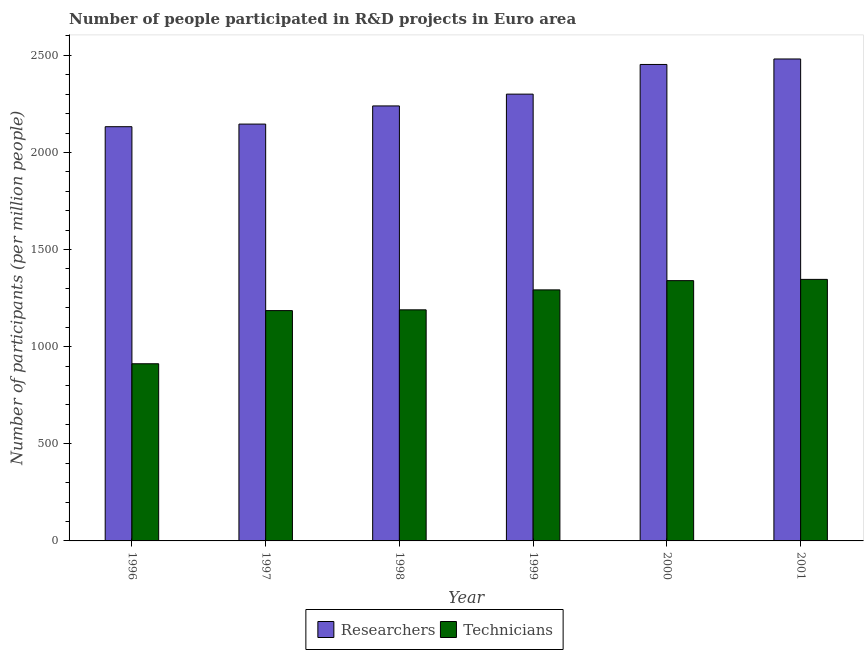How many different coloured bars are there?
Your response must be concise. 2. How many groups of bars are there?
Ensure brevity in your answer.  6. Are the number of bars per tick equal to the number of legend labels?
Ensure brevity in your answer.  Yes. What is the label of the 4th group of bars from the left?
Your response must be concise. 1999. What is the number of researchers in 1996?
Provide a short and direct response. 2132.59. Across all years, what is the maximum number of technicians?
Make the answer very short. 1346.52. Across all years, what is the minimum number of technicians?
Give a very brief answer. 912.13. In which year was the number of technicians maximum?
Your answer should be very brief. 2001. In which year was the number of technicians minimum?
Your answer should be very brief. 1996. What is the total number of researchers in the graph?
Provide a short and direct response. 1.38e+04. What is the difference between the number of technicians in 1999 and that in 2001?
Offer a terse response. -54.1. What is the difference between the number of researchers in 2000 and the number of technicians in 1996?
Your answer should be very brief. 320.41. What is the average number of technicians per year?
Your answer should be compact. 1211.11. What is the ratio of the number of technicians in 1996 to that in 2001?
Provide a short and direct response. 0.68. Is the number of researchers in 1997 less than that in 1999?
Provide a succinct answer. Yes. Is the difference between the number of researchers in 1998 and 2001 greater than the difference between the number of technicians in 1998 and 2001?
Provide a short and direct response. No. What is the difference between the highest and the second highest number of technicians?
Your response must be concise. 6.43. What is the difference between the highest and the lowest number of researchers?
Provide a short and direct response. 348.67. In how many years, is the number of technicians greater than the average number of technicians taken over all years?
Provide a succinct answer. 3. Is the sum of the number of researchers in 1996 and 2001 greater than the maximum number of technicians across all years?
Ensure brevity in your answer.  Yes. What does the 1st bar from the left in 1998 represents?
Ensure brevity in your answer.  Researchers. What does the 1st bar from the right in 1997 represents?
Your answer should be compact. Technicians. How many bars are there?
Offer a very short reply. 12. Are all the bars in the graph horizontal?
Offer a terse response. No. What is the difference between two consecutive major ticks on the Y-axis?
Give a very brief answer. 500. What is the title of the graph?
Your answer should be very brief. Number of people participated in R&D projects in Euro area. Does "All education staff compensation" appear as one of the legend labels in the graph?
Give a very brief answer. No. What is the label or title of the Y-axis?
Provide a short and direct response. Number of participants (per million people). What is the Number of participants (per million people) in Researchers in 1996?
Offer a very short reply. 2132.59. What is the Number of participants (per million people) in Technicians in 1996?
Offer a very short reply. 912.13. What is the Number of participants (per million people) in Researchers in 1997?
Give a very brief answer. 2146.05. What is the Number of participants (per million people) of Technicians in 1997?
Keep it short and to the point. 1185.77. What is the Number of participants (per million people) in Researchers in 1998?
Your response must be concise. 2239.52. What is the Number of participants (per million people) of Technicians in 1998?
Provide a succinct answer. 1189.74. What is the Number of participants (per million people) in Researchers in 1999?
Offer a very short reply. 2300.26. What is the Number of participants (per million people) of Technicians in 1999?
Offer a terse response. 1292.42. What is the Number of participants (per million people) in Researchers in 2000?
Make the answer very short. 2452.99. What is the Number of participants (per million people) of Technicians in 2000?
Give a very brief answer. 1340.09. What is the Number of participants (per million people) in Researchers in 2001?
Your answer should be compact. 2481.25. What is the Number of participants (per million people) in Technicians in 2001?
Ensure brevity in your answer.  1346.52. Across all years, what is the maximum Number of participants (per million people) of Researchers?
Keep it short and to the point. 2481.25. Across all years, what is the maximum Number of participants (per million people) of Technicians?
Your response must be concise. 1346.52. Across all years, what is the minimum Number of participants (per million people) in Researchers?
Give a very brief answer. 2132.59. Across all years, what is the minimum Number of participants (per million people) in Technicians?
Ensure brevity in your answer.  912.13. What is the total Number of participants (per million people) in Researchers in the graph?
Your answer should be compact. 1.38e+04. What is the total Number of participants (per million people) in Technicians in the graph?
Offer a very short reply. 7266.67. What is the difference between the Number of participants (per million people) of Researchers in 1996 and that in 1997?
Provide a short and direct response. -13.47. What is the difference between the Number of participants (per million people) in Technicians in 1996 and that in 1997?
Provide a succinct answer. -273.63. What is the difference between the Number of participants (per million people) of Researchers in 1996 and that in 1998?
Ensure brevity in your answer.  -106.94. What is the difference between the Number of participants (per million people) in Technicians in 1996 and that in 1998?
Ensure brevity in your answer.  -277.61. What is the difference between the Number of participants (per million people) in Researchers in 1996 and that in 1999?
Keep it short and to the point. -167.67. What is the difference between the Number of participants (per million people) of Technicians in 1996 and that in 1999?
Your answer should be very brief. -380.29. What is the difference between the Number of participants (per million people) in Researchers in 1996 and that in 2000?
Provide a short and direct response. -320.41. What is the difference between the Number of participants (per million people) of Technicians in 1996 and that in 2000?
Your response must be concise. -427.96. What is the difference between the Number of participants (per million people) in Researchers in 1996 and that in 2001?
Provide a succinct answer. -348.67. What is the difference between the Number of participants (per million people) of Technicians in 1996 and that in 2001?
Provide a succinct answer. -434.39. What is the difference between the Number of participants (per million people) of Researchers in 1997 and that in 1998?
Your answer should be compact. -93.47. What is the difference between the Number of participants (per million people) of Technicians in 1997 and that in 1998?
Offer a very short reply. -3.97. What is the difference between the Number of participants (per million people) in Researchers in 1997 and that in 1999?
Keep it short and to the point. -154.2. What is the difference between the Number of participants (per million people) of Technicians in 1997 and that in 1999?
Ensure brevity in your answer.  -106.66. What is the difference between the Number of participants (per million people) of Researchers in 1997 and that in 2000?
Keep it short and to the point. -306.94. What is the difference between the Number of participants (per million people) of Technicians in 1997 and that in 2000?
Offer a terse response. -154.33. What is the difference between the Number of participants (per million people) in Researchers in 1997 and that in 2001?
Offer a very short reply. -335.2. What is the difference between the Number of participants (per million people) in Technicians in 1997 and that in 2001?
Give a very brief answer. -160.75. What is the difference between the Number of participants (per million people) in Researchers in 1998 and that in 1999?
Ensure brevity in your answer.  -60.74. What is the difference between the Number of participants (per million people) of Technicians in 1998 and that in 1999?
Your answer should be compact. -102.68. What is the difference between the Number of participants (per million people) in Researchers in 1998 and that in 2000?
Offer a very short reply. -213.47. What is the difference between the Number of participants (per million people) of Technicians in 1998 and that in 2000?
Make the answer very short. -150.35. What is the difference between the Number of participants (per million people) of Researchers in 1998 and that in 2001?
Ensure brevity in your answer.  -241.73. What is the difference between the Number of participants (per million people) of Technicians in 1998 and that in 2001?
Your response must be concise. -156.78. What is the difference between the Number of participants (per million people) of Researchers in 1999 and that in 2000?
Make the answer very short. -152.73. What is the difference between the Number of participants (per million people) in Technicians in 1999 and that in 2000?
Give a very brief answer. -47.67. What is the difference between the Number of participants (per million people) in Researchers in 1999 and that in 2001?
Give a very brief answer. -181. What is the difference between the Number of participants (per million people) in Technicians in 1999 and that in 2001?
Make the answer very short. -54.1. What is the difference between the Number of participants (per million people) in Researchers in 2000 and that in 2001?
Offer a very short reply. -28.26. What is the difference between the Number of participants (per million people) in Technicians in 2000 and that in 2001?
Ensure brevity in your answer.  -6.43. What is the difference between the Number of participants (per million people) of Researchers in 1996 and the Number of participants (per million people) of Technicians in 1997?
Offer a terse response. 946.82. What is the difference between the Number of participants (per million people) of Researchers in 1996 and the Number of participants (per million people) of Technicians in 1998?
Provide a short and direct response. 942.85. What is the difference between the Number of participants (per million people) in Researchers in 1996 and the Number of participants (per million people) in Technicians in 1999?
Offer a very short reply. 840.16. What is the difference between the Number of participants (per million people) of Researchers in 1996 and the Number of participants (per million people) of Technicians in 2000?
Your answer should be compact. 792.49. What is the difference between the Number of participants (per million people) in Researchers in 1996 and the Number of participants (per million people) in Technicians in 2001?
Your answer should be compact. 786.07. What is the difference between the Number of participants (per million people) of Researchers in 1997 and the Number of participants (per million people) of Technicians in 1998?
Make the answer very short. 956.31. What is the difference between the Number of participants (per million people) of Researchers in 1997 and the Number of participants (per million people) of Technicians in 1999?
Make the answer very short. 853.63. What is the difference between the Number of participants (per million people) of Researchers in 1997 and the Number of participants (per million people) of Technicians in 2000?
Keep it short and to the point. 805.96. What is the difference between the Number of participants (per million people) of Researchers in 1997 and the Number of participants (per million people) of Technicians in 2001?
Make the answer very short. 799.53. What is the difference between the Number of participants (per million people) in Researchers in 1998 and the Number of participants (per million people) in Technicians in 1999?
Your answer should be very brief. 947.1. What is the difference between the Number of participants (per million people) in Researchers in 1998 and the Number of participants (per million people) in Technicians in 2000?
Provide a short and direct response. 899.43. What is the difference between the Number of participants (per million people) in Researchers in 1998 and the Number of participants (per million people) in Technicians in 2001?
Give a very brief answer. 893. What is the difference between the Number of participants (per million people) in Researchers in 1999 and the Number of participants (per million people) in Technicians in 2000?
Give a very brief answer. 960.17. What is the difference between the Number of participants (per million people) of Researchers in 1999 and the Number of participants (per million people) of Technicians in 2001?
Give a very brief answer. 953.74. What is the difference between the Number of participants (per million people) in Researchers in 2000 and the Number of participants (per million people) in Technicians in 2001?
Provide a short and direct response. 1106.47. What is the average Number of participants (per million people) of Researchers per year?
Offer a terse response. 2292.11. What is the average Number of participants (per million people) in Technicians per year?
Keep it short and to the point. 1211.11. In the year 1996, what is the difference between the Number of participants (per million people) in Researchers and Number of participants (per million people) in Technicians?
Give a very brief answer. 1220.45. In the year 1997, what is the difference between the Number of participants (per million people) of Researchers and Number of participants (per million people) of Technicians?
Offer a terse response. 960.29. In the year 1998, what is the difference between the Number of participants (per million people) of Researchers and Number of participants (per million people) of Technicians?
Give a very brief answer. 1049.78. In the year 1999, what is the difference between the Number of participants (per million people) of Researchers and Number of participants (per million people) of Technicians?
Keep it short and to the point. 1007.84. In the year 2000, what is the difference between the Number of participants (per million people) of Researchers and Number of participants (per million people) of Technicians?
Give a very brief answer. 1112.9. In the year 2001, what is the difference between the Number of participants (per million people) of Researchers and Number of participants (per million people) of Technicians?
Your answer should be very brief. 1134.73. What is the ratio of the Number of participants (per million people) of Researchers in 1996 to that in 1997?
Keep it short and to the point. 0.99. What is the ratio of the Number of participants (per million people) of Technicians in 1996 to that in 1997?
Your answer should be compact. 0.77. What is the ratio of the Number of participants (per million people) in Researchers in 1996 to that in 1998?
Offer a very short reply. 0.95. What is the ratio of the Number of participants (per million people) in Technicians in 1996 to that in 1998?
Provide a succinct answer. 0.77. What is the ratio of the Number of participants (per million people) of Researchers in 1996 to that in 1999?
Ensure brevity in your answer.  0.93. What is the ratio of the Number of participants (per million people) of Technicians in 1996 to that in 1999?
Give a very brief answer. 0.71. What is the ratio of the Number of participants (per million people) of Researchers in 1996 to that in 2000?
Keep it short and to the point. 0.87. What is the ratio of the Number of participants (per million people) in Technicians in 1996 to that in 2000?
Your answer should be compact. 0.68. What is the ratio of the Number of participants (per million people) in Researchers in 1996 to that in 2001?
Give a very brief answer. 0.86. What is the ratio of the Number of participants (per million people) in Technicians in 1996 to that in 2001?
Your answer should be very brief. 0.68. What is the ratio of the Number of participants (per million people) in Researchers in 1997 to that in 1999?
Offer a terse response. 0.93. What is the ratio of the Number of participants (per million people) of Technicians in 1997 to that in 1999?
Provide a succinct answer. 0.92. What is the ratio of the Number of participants (per million people) of Researchers in 1997 to that in 2000?
Offer a very short reply. 0.87. What is the ratio of the Number of participants (per million people) of Technicians in 1997 to that in 2000?
Offer a terse response. 0.88. What is the ratio of the Number of participants (per million people) in Researchers in 1997 to that in 2001?
Your answer should be compact. 0.86. What is the ratio of the Number of participants (per million people) in Technicians in 1997 to that in 2001?
Your response must be concise. 0.88. What is the ratio of the Number of participants (per million people) in Researchers in 1998 to that in 1999?
Offer a very short reply. 0.97. What is the ratio of the Number of participants (per million people) in Technicians in 1998 to that in 1999?
Your answer should be very brief. 0.92. What is the ratio of the Number of participants (per million people) in Technicians in 1998 to that in 2000?
Ensure brevity in your answer.  0.89. What is the ratio of the Number of participants (per million people) in Researchers in 1998 to that in 2001?
Give a very brief answer. 0.9. What is the ratio of the Number of participants (per million people) in Technicians in 1998 to that in 2001?
Make the answer very short. 0.88. What is the ratio of the Number of participants (per million people) of Researchers in 1999 to that in 2000?
Offer a very short reply. 0.94. What is the ratio of the Number of participants (per million people) of Technicians in 1999 to that in 2000?
Offer a very short reply. 0.96. What is the ratio of the Number of participants (per million people) of Researchers in 1999 to that in 2001?
Offer a terse response. 0.93. What is the ratio of the Number of participants (per million people) of Technicians in 1999 to that in 2001?
Keep it short and to the point. 0.96. What is the ratio of the Number of participants (per million people) in Technicians in 2000 to that in 2001?
Your response must be concise. 1. What is the difference between the highest and the second highest Number of participants (per million people) in Researchers?
Keep it short and to the point. 28.26. What is the difference between the highest and the second highest Number of participants (per million people) of Technicians?
Your answer should be very brief. 6.43. What is the difference between the highest and the lowest Number of participants (per million people) in Researchers?
Offer a very short reply. 348.67. What is the difference between the highest and the lowest Number of participants (per million people) in Technicians?
Your answer should be compact. 434.39. 